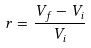Convert formula to latex. <formula><loc_0><loc_0><loc_500><loc_500>r = \frac { V _ { f } - V _ { i } } { V _ { i } }</formula> 